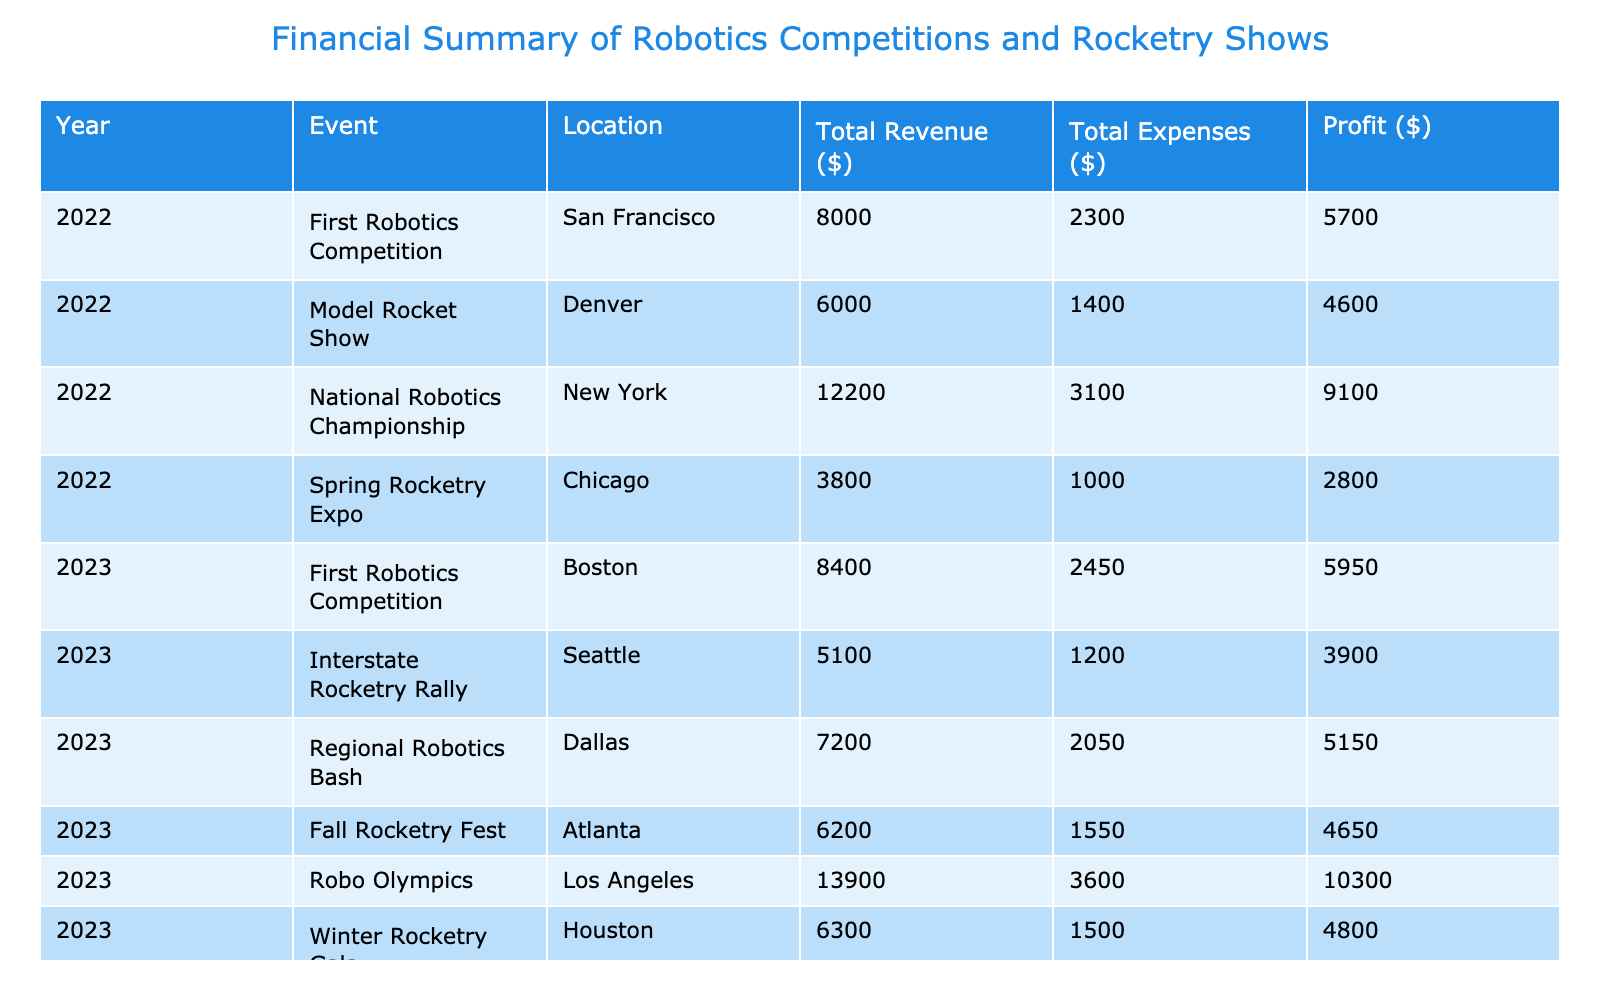What was the total revenue for the National Robotics Championship in 2022? The total revenue is calculated by adding the sponsorship, sales of models, and earnings from prizes. For the National Robotics Championship in 2022, the values are: Sponsorship ($3000) + Sales of Models ($1200) + Earnings from Prizes ($8000) = $3000 + $1200 + $8000 = $12200.
Answer: 12200 Which event in 2023 had the highest profit? To find the event with the highest profit, we must look at the profit values for each event in 2023. The profit for each event is: First Robotics Competition ($4650), Interstate Rocketry Rally ($1950), Regional Robotics Bash ($3600), Fall Rocketry Fest ($3100), Robo Olympics ($14000), Winter Rocketry Gala ($2100). The highest profit is $14000 for the Robo Olympics.
Answer: Robo Olympics Was the total expenses lower than total revenue for all events in 2022? To answer this, we need to check if total revenue exceeds total expenses for each event in 2022. For First Robotics Competition, the total revenue is $6000 and total expenses is $2300; for Model Rocket Show, it is $4500 vs. $1400; for National Robotics Championship, it is $12200 vs. $3200; for Spring Rocketry Expo, it is $3000 vs. $1000. All show that revenue is higher than expenses, so yes, it is true for all events.
Answer: Yes What was the average profit of all events in 2023? To find the average profit, we need to sum the profits of all events in 2023 and divide by the number of events. The profits for 2023 are: $4650, $1950, $3600, $3100, $14000, and $2100. The total profit is $4650 + $1950 + $3600 + $3100 + $14000 + $2100 = $30000. Since there are 6 events, the average profit is $30000 / 6 = $5000.
Answer: 5000 Did participating in the Fall Rocketry Fest incur more material costs than the First Robotics Competition in 2023? For the Fall Rocketry Fest, material costs are $800, while for the First Robotics Competition they are $1250. Since $800 is less than $1250, it is false that the Fall Rocketry Fest incurred more material costs.
Answer: No 